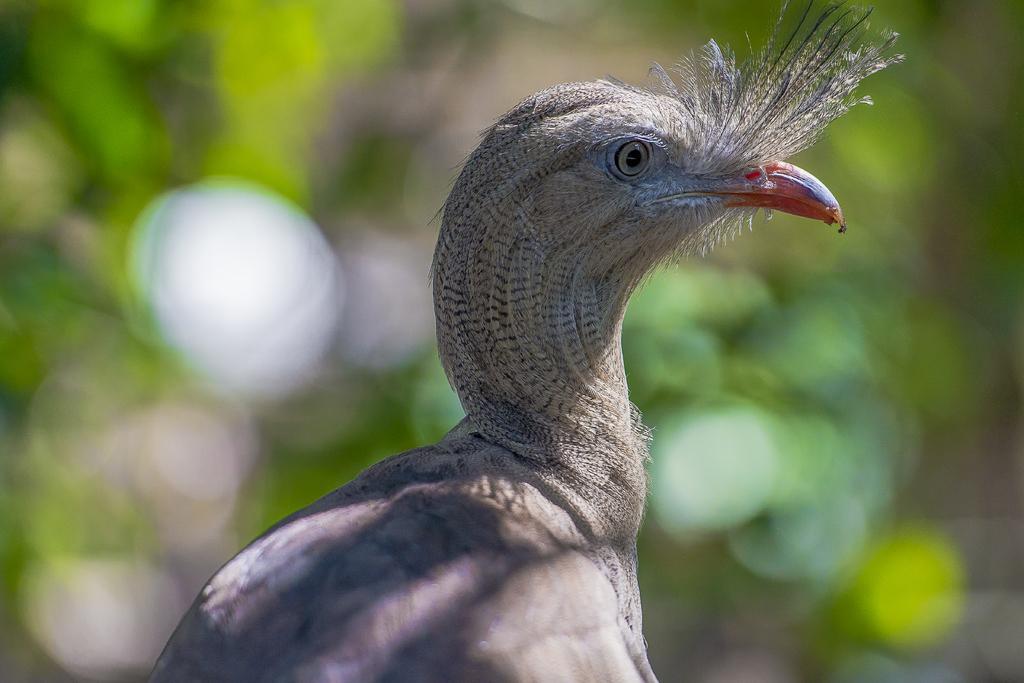How would you summarize this image in a sentence or two? In this image I can see a bird which is in grey and white color. Background is in green color and it is blurred. 